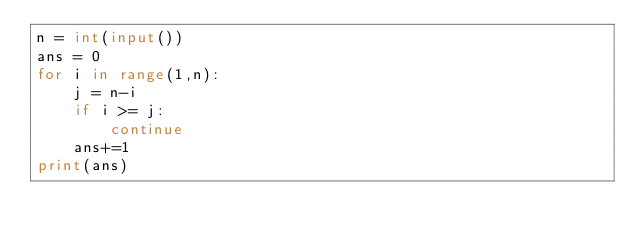Convert code to text. <code><loc_0><loc_0><loc_500><loc_500><_Python_>n = int(input())
ans = 0
for i in range(1,n):
    j = n-i
    if i >= j:
        continue
    ans+=1
print(ans)</code> 